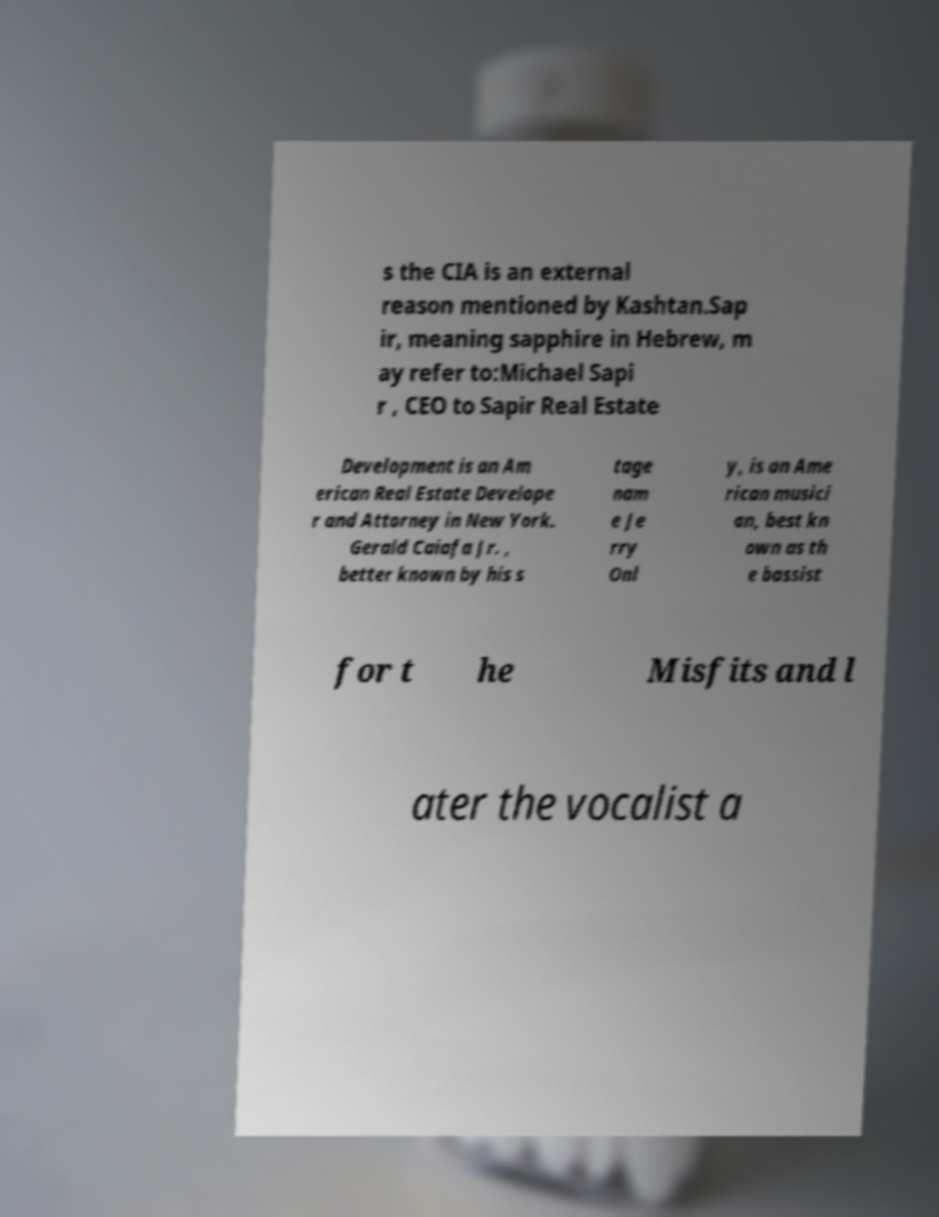What messages or text are displayed in this image? I need them in a readable, typed format. s the CIA is an external reason mentioned by Kashtan.Sap ir, meaning sapphire in Hebrew, m ay refer to:Michael Sapi r , CEO to Sapir Real Estate Development is an Am erican Real Estate Develope r and Attorney in New York. Gerald Caiafa Jr. , better known by his s tage nam e Je rry Onl y, is an Ame rican musici an, best kn own as th e bassist for t he Misfits and l ater the vocalist a 